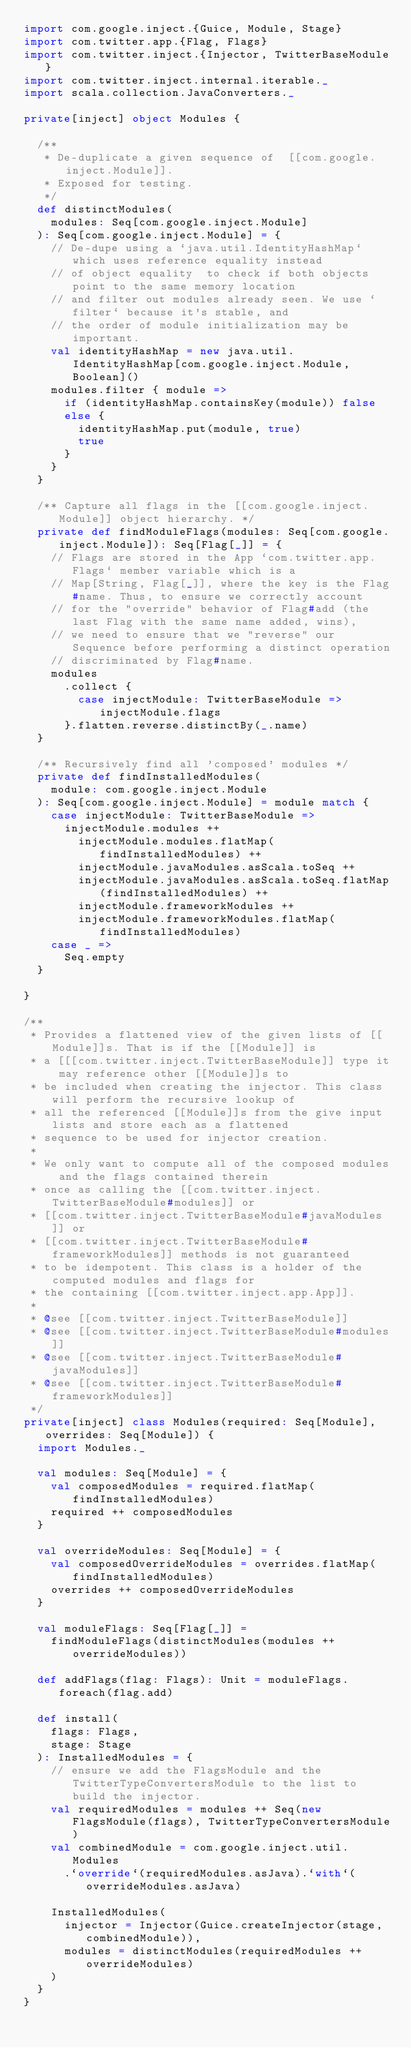Convert code to text. <code><loc_0><loc_0><loc_500><loc_500><_Scala_>import com.google.inject.{Guice, Module, Stage}
import com.twitter.app.{Flag, Flags}
import com.twitter.inject.{Injector, TwitterBaseModule}
import com.twitter.inject.internal.iterable._
import scala.collection.JavaConverters._

private[inject] object Modules {

  /**
   * De-duplicate a given sequence of  [[com.google.inject.Module]].
   * Exposed for testing.
   */
  def distinctModules(
    modules: Seq[com.google.inject.Module]
  ): Seq[com.google.inject.Module] = {
    // De-dupe using a `java.util.IdentityHashMap` which uses reference equality instead
    // of object equality  to check if both objects point to the same memory location
    // and filter out modules already seen. We use `filter` because it's stable, and
    // the order of module initialization may be important.
    val identityHashMap = new java.util.IdentityHashMap[com.google.inject.Module, Boolean]()
    modules.filter { module =>
      if (identityHashMap.containsKey(module)) false
      else {
        identityHashMap.put(module, true)
        true
      }
    }
  }

  /** Capture all flags in the [[com.google.inject.Module]] object hierarchy. */
  private def findModuleFlags(modules: Seq[com.google.inject.Module]): Seq[Flag[_]] = {
    // Flags are stored in the App `com.twitter.app.Flags` member variable which is a
    // Map[String, Flag[_]], where the key is the Flag#name. Thus, to ensure we correctly account
    // for the "override" behavior of Flag#add (the last Flag with the same name added, wins),
    // we need to ensure that we "reverse" our Sequence before performing a distinct operation
    // discriminated by Flag#name.
    modules
      .collect {
        case injectModule: TwitterBaseModule => injectModule.flags
      }.flatten.reverse.distinctBy(_.name)
  }

  /** Recursively find all 'composed' modules */
  private def findInstalledModules(
    module: com.google.inject.Module
  ): Seq[com.google.inject.Module] = module match {
    case injectModule: TwitterBaseModule =>
      injectModule.modules ++
        injectModule.modules.flatMap(findInstalledModules) ++
        injectModule.javaModules.asScala.toSeq ++
        injectModule.javaModules.asScala.toSeq.flatMap(findInstalledModules) ++
        injectModule.frameworkModules ++
        injectModule.frameworkModules.flatMap(findInstalledModules)
    case _ =>
      Seq.empty
  }

}

/**
 * Provides a flattened view of the given lists of [[Module]]s. That is if the [[Module]] is
 * a [[[com.twitter.inject.TwitterBaseModule]] type it may reference other [[Module]]s to
 * be included when creating the injector. This class will perform the recursive lookup of
 * all the referenced [[Module]]s from the give input lists and store each as a flattened
 * sequence to be used for injector creation.
 *
 * We only want to compute all of the composed modules and the flags contained therein
 * once as calling the [[com.twitter.inject.TwitterBaseModule#modules]] or
 * [[com.twitter.inject.TwitterBaseModule#javaModules]] or
 * [[com.twitter.inject.TwitterBaseModule#frameworkModules]] methods is not guaranteed
 * to be idempotent. This class is a holder of the computed modules and flags for
 * the containing [[com.twitter.inject.app.App]].
 *
 * @see [[com.twitter.inject.TwitterBaseModule]]
 * @see [[com.twitter.inject.TwitterBaseModule#modules]]
 * @see [[com.twitter.inject.TwitterBaseModule#javaModules]]
 * @see [[com.twitter.inject.TwitterBaseModule#frameworkModules]]
 */
private[inject] class Modules(required: Seq[Module], overrides: Seq[Module]) {
  import Modules._

  val modules: Seq[Module] = {
    val composedModules = required.flatMap(findInstalledModules)
    required ++ composedModules
  }

  val overrideModules: Seq[Module] = {
    val composedOverrideModules = overrides.flatMap(findInstalledModules)
    overrides ++ composedOverrideModules
  }

  val moduleFlags: Seq[Flag[_]] =
    findModuleFlags(distinctModules(modules ++ overrideModules))

  def addFlags(flag: Flags): Unit = moduleFlags.foreach(flag.add)

  def install(
    flags: Flags,
    stage: Stage
  ): InstalledModules = {
    // ensure we add the FlagsModule and the TwitterTypeConvertersModule to the list to build the injector.
    val requiredModules = modules ++ Seq(new FlagsModule(flags), TwitterTypeConvertersModule)
    val combinedModule = com.google.inject.util.Modules
      .`override`(requiredModules.asJava).`with`(overrideModules.asJava)

    InstalledModules(
      injector = Injector(Guice.createInjector(stage, combinedModule)),
      modules = distinctModules(requiredModules ++ overrideModules)
    )
  }
}
</code> 